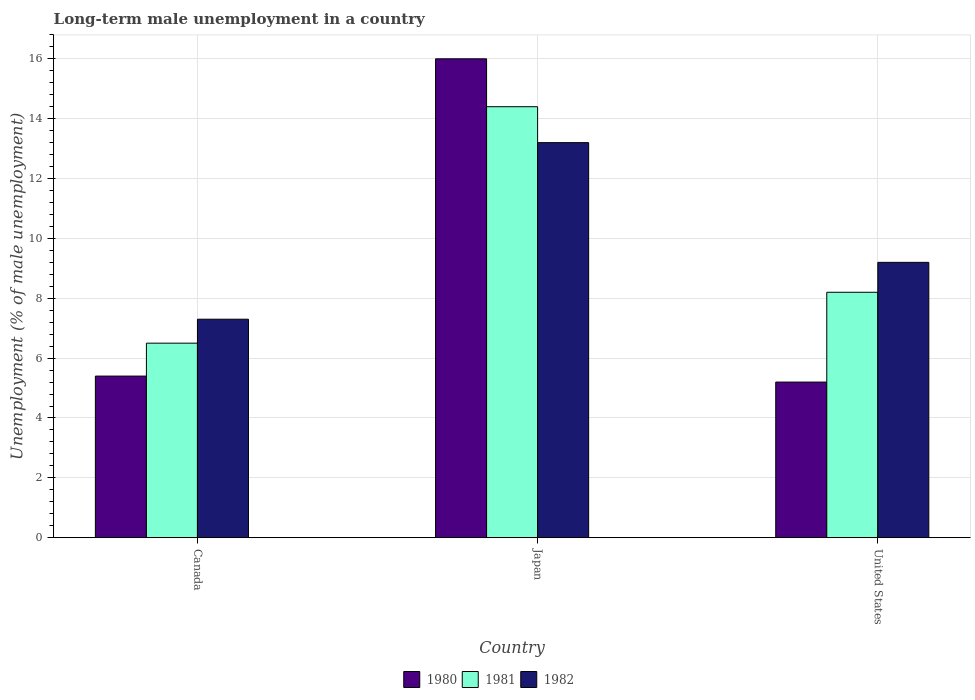How many different coloured bars are there?
Your response must be concise. 3. How many bars are there on the 3rd tick from the left?
Your answer should be very brief. 3. In how many cases, is the number of bars for a given country not equal to the number of legend labels?
Provide a short and direct response. 0. What is the percentage of long-term unemployed male population in 1982 in United States?
Offer a terse response. 9.2. Across all countries, what is the minimum percentage of long-term unemployed male population in 1980?
Ensure brevity in your answer.  5.2. In which country was the percentage of long-term unemployed male population in 1981 maximum?
Your answer should be very brief. Japan. What is the total percentage of long-term unemployed male population in 1981 in the graph?
Offer a very short reply. 29.1. What is the difference between the percentage of long-term unemployed male population in 1982 in Japan and that in United States?
Your response must be concise. 4. What is the difference between the percentage of long-term unemployed male population in 1981 in Canada and the percentage of long-term unemployed male population in 1982 in United States?
Ensure brevity in your answer.  -2.7. What is the average percentage of long-term unemployed male population in 1980 per country?
Keep it short and to the point. 8.87. What is the difference between the percentage of long-term unemployed male population of/in 1982 and percentage of long-term unemployed male population of/in 1980 in United States?
Offer a terse response. 4. What is the ratio of the percentage of long-term unemployed male population in 1981 in Canada to that in United States?
Keep it short and to the point. 0.79. What is the difference between the highest and the second highest percentage of long-term unemployed male population in 1981?
Offer a very short reply. -6.2. What is the difference between the highest and the lowest percentage of long-term unemployed male population in 1982?
Keep it short and to the point. 5.9. In how many countries, is the percentage of long-term unemployed male population in 1982 greater than the average percentage of long-term unemployed male population in 1982 taken over all countries?
Ensure brevity in your answer.  1. What does the 1st bar from the left in Canada represents?
Your answer should be compact. 1980. What does the 2nd bar from the right in Canada represents?
Provide a succinct answer. 1981. Is it the case that in every country, the sum of the percentage of long-term unemployed male population in 1982 and percentage of long-term unemployed male population in 1980 is greater than the percentage of long-term unemployed male population in 1981?
Make the answer very short. Yes. How many bars are there?
Your response must be concise. 9. What is the difference between two consecutive major ticks on the Y-axis?
Make the answer very short. 2. Are the values on the major ticks of Y-axis written in scientific E-notation?
Provide a short and direct response. No. Does the graph contain any zero values?
Offer a terse response. No. Where does the legend appear in the graph?
Ensure brevity in your answer.  Bottom center. How many legend labels are there?
Give a very brief answer. 3. What is the title of the graph?
Offer a terse response. Long-term male unemployment in a country. Does "2015" appear as one of the legend labels in the graph?
Offer a terse response. No. What is the label or title of the Y-axis?
Your answer should be compact. Unemployment (% of male unemployment). What is the Unemployment (% of male unemployment) of 1980 in Canada?
Offer a terse response. 5.4. What is the Unemployment (% of male unemployment) of 1981 in Canada?
Your response must be concise. 6.5. What is the Unemployment (% of male unemployment) of 1982 in Canada?
Keep it short and to the point. 7.3. What is the Unemployment (% of male unemployment) in 1980 in Japan?
Make the answer very short. 16. What is the Unemployment (% of male unemployment) in 1981 in Japan?
Make the answer very short. 14.4. What is the Unemployment (% of male unemployment) in 1982 in Japan?
Your response must be concise. 13.2. What is the Unemployment (% of male unemployment) of 1980 in United States?
Offer a terse response. 5.2. What is the Unemployment (% of male unemployment) of 1981 in United States?
Keep it short and to the point. 8.2. What is the Unemployment (% of male unemployment) in 1982 in United States?
Give a very brief answer. 9.2. Across all countries, what is the maximum Unemployment (% of male unemployment) in 1980?
Provide a short and direct response. 16. Across all countries, what is the maximum Unemployment (% of male unemployment) in 1981?
Your response must be concise. 14.4. Across all countries, what is the maximum Unemployment (% of male unemployment) in 1982?
Offer a terse response. 13.2. Across all countries, what is the minimum Unemployment (% of male unemployment) of 1980?
Make the answer very short. 5.2. Across all countries, what is the minimum Unemployment (% of male unemployment) of 1982?
Keep it short and to the point. 7.3. What is the total Unemployment (% of male unemployment) in 1980 in the graph?
Your answer should be very brief. 26.6. What is the total Unemployment (% of male unemployment) of 1981 in the graph?
Your response must be concise. 29.1. What is the total Unemployment (% of male unemployment) in 1982 in the graph?
Give a very brief answer. 29.7. What is the difference between the Unemployment (% of male unemployment) in 1980 in Canada and that in Japan?
Give a very brief answer. -10.6. What is the difference between the Unemployment (% of male unemployment) in 1981 in Canada and that in Japan?
Offer a terse response. -7.9. What is the difference between the Unemployment (% of male unemployment) of 1982 in Canada and that in United States?
Ensure brevity in your answer.  -1.9. What is the difference between the Unemployment (% of male unemployment) of 1981 in Japan and that in United States?
Your response must be concise. 6.2. What is the difference between the Unemployment (% of male unemployment) in 1980 in Canada and the Unemployment (% of male unemployment) in 1981 in Japan?
Your response must be concise. -9. What is the difference between the Unemployment (% of male unemployment) in 1980 in Canada and the Unemployment (% of male unemployment) in 1982 in United States?
Ensure brevity in your answer.  -3.8. What is the difference between the Unemployment (% of male unemployment) of 1981 in Canada and the Unemployment (% of male unemployment) of 1982 in United States?
Make the answer very short. -2.7. What is the difference between the Unemployment (% of male unemployment) of 1980 in Japan and the Unemployment (% of male unemployment) of 1981 in United States?
Provide a succinct answer. 7.8. What is the difference between the Unemployment (% of male unemployment) of 1980 in Japan and the Unemployment (% of male unemployment) of 1982 in United States?
Your answer should be compact. 6.8. What is the average Unemployment (% of male unemployment) of 1980 per country?
Keep it short and to the point. 8.87. What is the average Unemployment (% of male unemployment) in 1981 per country?
Provide a succinct answer. 9.7. What is the difference between the Unemployment (% of male unemployment) of 1980 and Unemployment (% of male unemployment) of 1982 in Canada?
Keep it short and to the point. -1.9. What is the difference between the Unemployment (% of male unemployment) in 1981 and Unemployment (% of male unemployment) in 1982 in Canada?
Make the answer very short. -0.8. What is the difference between the Unemployment (% of male unemployment) in 1980 and Unemployment (% of male unemployment) in 1981 in Japan?
Provide a short and direct response. 1.6. What is the difference between the Unemployment (% of male unemployment) in 1980 and Unemployment (% of male unemployment) in 1982 in United States?
Keep it short and to the point. -4. What is the difference between the Unemployment (% of male unemployment) in 1981 and Unemployment (% of male unemployment) in 1982 in United States?
Ensure brevity in your answer.  -1. What is the ratio of the Unemployment (% of male unemployment) in 1980 in Canada to that in Japan?
Give a very brief answer. 0.34. What is the ratio of the Unemployment (% of male unemployment) of 1981 in Canada to that in Japan?
Your answer should be compact. 0.45. What is the ratio of the Unemployment (% of male unemployment) of 1982 in Canada to that in Japan?
Ensure brevity in your answer.  0.55. What is the ratio of the Unemployment (% of male unemployment) in 1980 in Canada to that in United States?
Make the answer very short. 1.04. What is the ratio of the Unemployment (% of male unemployment) of 1981 in Canada to that in United States?
Ensure brevity in your answer.  0.79. What is the ratio of the Unemployment (% of male unemployment) in 1982 in Canada to that in United States?
Your response must be concise. 0.79. What is the ratio of the Unemployment (% of male unemployment) in 1980 in Japan to that in United States?
Provide a succinct answer. 3.08. What is the ratio of the Unemployment (% of male unemployment) in 1981 in Japan to that in United States?
Make the answer very short. 1.76. What is the ratio of the Unemployment (% of male unemployment) in 1982 in Japan to that in United States?
Make the answer very short. 1.43. What is the difference between the highest and the second highest Unemployment (% of male unemployment) in 1980?
Keep it short and to the point. 10.6. What is the difference between the highest and the second highest Unemployment (% of male unemployment) in 1982?
Keep it short and to the point. 4. What is the difference between the highest and the lowest Unemployment (% of male unemployment) in 1980?
Your answer should be compact. 10.8. What is the difference between the highest and the lowest Unemployment (% of male unemployment) of 1981?
Your response must be concise. 7.9. What is the difference between the highest and the lowest Unemployment (% of male unemployment) of 1982?
Your answer should be compact. 5.9. 